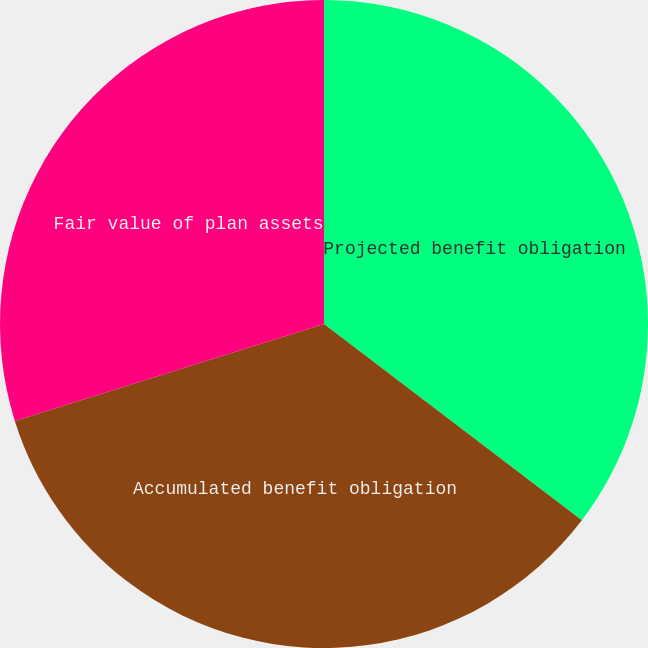Convert chart to OTSL. <chart><loc_0><loc_0><loc_500><loc_500><pie_chart><fcel>Projected benefit obligation<fcel>Accumulated benefit obligation<fcel>Fair value of plan assets<nl><fcel>35.35%<fcel>34.81%<fcel>29.83%<nl></chart> 